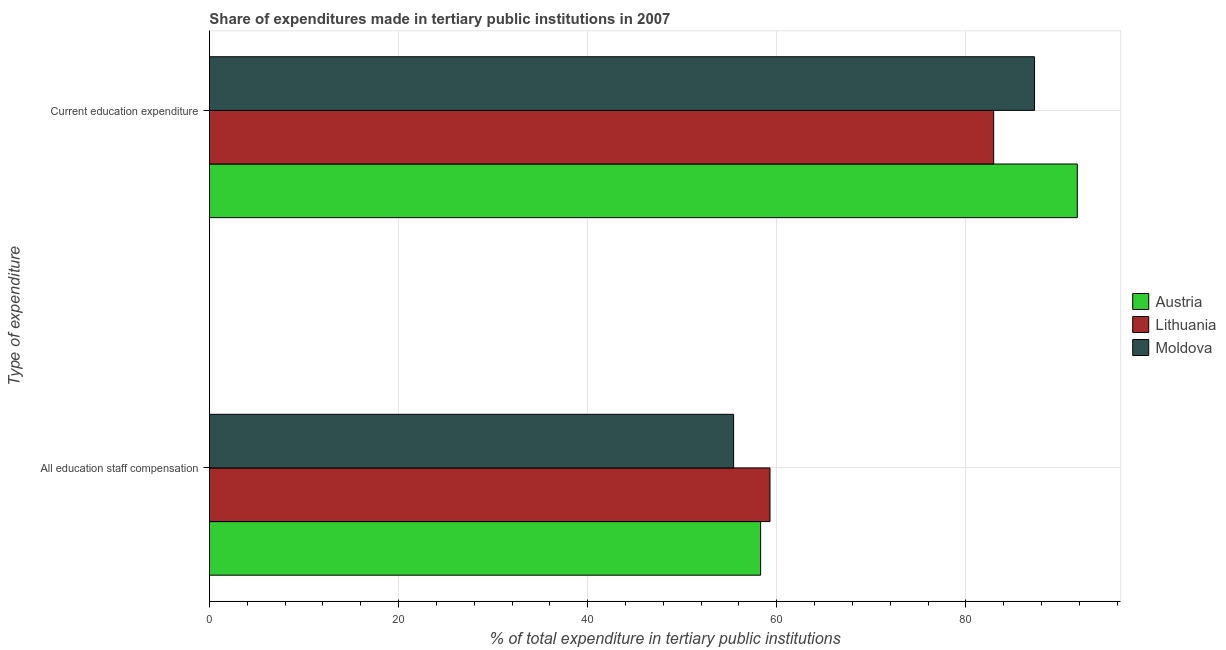Are the number of bars on each tick of the Y-axis equal?
Give a very brief answer. Yes. How many bars are there on the 2nd tick from the bottom?
Make the answer very short. 3. What is the label of the 2nd group of bars from the top?
Provide a succinct answer. All education staff compensation. What is the expenditure in staff compensation in Austria?
Provide a succinct answer. 58.29. Across all countries, what is the maximum expenditure in education?
Offer a very short reply. 91.79. Across all countries, what is the minimum expenditure in staff compensation?
Keep it short and to the point. 55.44. In which country was the expenditure in education maximum?
Your answer should be very brief. Austria. In which country was the expenditure in staff compensation minimum?
Keep it short and to the point. Moldova. What is the total expenditure in staff compensation in the graph?
Your answer should be very brief. 173.02. What is the difference between the expenditure in education in Moldova and that in Lithuania?
Offer a very short reply. 4.32. What is the difference between the expenditure in staff compensation in Moldova and the expenditure in education in Lithuania?
Offer a very short reply. -27.5. What is the average expenditure in staff compensation per country?
Keep it short and to the point. 57.67. What is the difference between the expenditure in education and expenditure in staff compensation in Moldova?
Offer a very short reply. 31.83. What is the ratio of the expenditure in education in Austria to that in Moldova?
Offer a terse response. 1.05. Is the expenditure in education in Austria less than that in Moldova?
Ensure brevity in your answer.  No. In how many countries, is the expenditure in staff compensation greater than the average expenditure in staff compensation taken over all countries?
Ensure brevity in your answer.  2. What does the 2nd bar from the top in All education staff compensation represents?
Give a very brief answer. Lithuania. What does the 2nd bar from the bottom in Current education expenditure represents?
Your answer should be very brief. Lithuania. How many bars are there?
Ensure brevity in your answer.  6. How many countries are there in the graph?
Your answer should be compact. 3. What is the difference between two consecutive major ticks on the X-axis?
Keep it short and to the point. 20. Are the values on the major ticks of X-axis written in scientific E-notation?
Provide a succinct answer. No. Where does the legend appear in the graph?
Offer a terse response. Center right. What is the title of the graph?
Give a very brief answer. Share of expenditures made in tertiary public institutions in 2007. Does "Georgia" appear as one of the legend labels in the graph?
Give a very brief answer. No. What is the label or title of the X-axis?
Ensure brevity in your answer.  % of total expenditure in tertiary public institutions. What is the label or title of the Y-axis?
Your response must be concise. Type of expenditure. What is the % of total expenditure in tertiary public institutions in Austria in All education staff compensation?
Your answer should be very brief. 58.29. What is the % of total expenditure in tertiary public institutions of Lithuania in All education staff compensation?
Ensure brevity in your answer.  59.29. What is the % of total expenditure in tertiary public institutions of Moldova in All education staff compensation?
Offer a very short reply. 55.44. What is the % of total expenditure in tertiary public institutions of Austria in Current education expenditure?
Ensure brevity in your answer.  91.79. What is the % of total expenditure in tertiary public institutions of Lithuania in Current education expenditure?
Your response must be concise. 82.94. What is the % of total expenditure in tertiary public institutions of Moldova in Current education expenditure?
Your response must be concise. 87.26. Across all Type of expenditure, what is the maximum % of total expenditure in tertiary public institutions in Austria?
Offer a terse response. 91.79. Across all Type of expenditure, what is the maximum % of total expenditure in tertiary public institutions in Lithuania?
Offer a terse response. 82.94. Across all Type of expenditure, what is the maximum % of total expenditure in tertiary public institutions in Moldova?
Ensure brevity in your answer.  87.26. Across all Type of expenditure, what is the minimum % of total expenditure in tertiary public institutions in Austria?
Give a very brief answer. 58.29. Across all Type of expenditure, what is the minimum % of total expenditure in tertiary public institutions in Lithuania?
Your response must be concise. 59.29. Across all Type of expenditure, what is the minimum % of total expenditure in tertiary public institutions in Moldova?
Keep it short and to the point. 55.44. What is the total % of total expenditure in tertiary public institutions in Austria in the graph?
Your response must be concise. 150.08. What is the total % of total expenditure in tertiary public institutions in Lithuania in the graph?
Keep it short and to the point. 142.23. What is the total % of total expenditure in tertiary public institutions of Moldova in the graph?
Make the answer very short. 142.7. What is the difference between the % of total expenditure in tertiary public institutions of Austria in All education staff compensation and that in Current education expenditure?
Offer a terse response. -33.49. What is the difference between the % of total expenditure in tertiary public institutions of Lithuania in All education staff compensation and that in Current education expenditure?
Your answer should be very brief. -23.66. What is the difference between the % of total expenditure in tertiary public institutions of Moldova in All education staff compensation and that in Current education expenditure?
Offer a terse response. -31.83. What is the difference between the % of total expenditure in tertiary public institutions of Austria in All education staff compensation and the % of total expenditure in tertiary public institutions of Lithuania in Current education expenditure?
Your answer should be very brief. -24.65. What is the difference between the % of total expenditure in tertiary public institutions in Austria in All education staff compensation and the % of total expenditure in tertiary public institutions in Moldova in Current education expenditure?
Provide a succinct answer. -28.97. What is the difference between the % of total expenditure in tertiary public institutions in Lithuania in All education staff compensation and the % of total expenditure in tertiary public institutions in Moldova in Current education expenditure?
Keep it short and to the point. -27.98. What is the average % of total expenditure in tertiary public institutions of Austria per Type of expenditure?
Offer a very short reply. 75.04. What is the average % of total expenditure in tertiary public institutions of Lithuania per Type of expenditure?
Keep it short and to the point. 71.11. What is the average % of total expenditure in tertiary public institutions in Moldova per Type of expenditure?
Your answer should be very brief. 71.35. What is the difference between the % of total expenditure in tertiary public institutions in Austria and % of total expenditure in tertiary public institutions in Lithuania in All education staff compensation?
Provide a succinct answer. -0.99. What is the difference between the % of total expenditure in tertiary public institutions in Austria and % of total expenditure in tertiary public institutions in Moldova in All education staff compensation?
Your response must be concise. 2.86. What is the difference between the % of total expenditure in tertiary public institutions in Lithuania and % of total expenditure in tertiary public institutions in Moldova in All education staff compensation?
Make the answer very short. 3.85. What is the difference between the % of total expenditure in tertiary public institutions in Austria and % of total expenditure in tertiary public institutions in Lithuania in Current education expenditure?
Keep it short and to the point. 8.85. What is the difference between the % of total expenditure in tertiary public institutions of Austria and % of total expenditure in tertiary public institutions of Moldova in Current education expenditure?
Offer a terse response. 4.52. What is the difference between the % of total expenditure in tertiary public institutions of Lithuania and % of total expenditure in tertiary public institutions of Moldova in Current education expenditure?
Ensure brevity in your answer.  -4.32. What is the ratio of the % of total expenditure in tertiary public institutions in Austria in All education staff compensation to that in Current education expenditure?
Give a very brief answer. 0.64. What is the ratio of the % of total expenditure in tertiary public institutions of Lithuania in All education staff compensation to that in Current education expenditure?
Your response must be concise. 0.71. What is the ratio of the % of total expenditure in tertiary public institutions of Moldova in All education staff compensation to that in Current education expenditure?
Offer a very short reply. 0.64. What is the difference between the highest and the second highest % of total expenditure in tertiary public institutions in Austria?
Ensure brevity in your answer.  33.49. What is the difference between the highest and the second highest % of total expenditure in tertiary public institutions in Lithuania?
Make the answer very short. 23.66. What is the difference between the highest and the second highest % of total expenditure in tertiary public institutions in Moldova?
Your answer should be compact. 31.83. What is the difference between the highest and the lowest % of total expenditure in tertiary public institutions in Austria?
Your response must be concise. 33.49. What is the difference between the highest and the lowest % of total expenditure in tertiary public institutions in Lithuania?
Offer a terse response. 23.66. What is the difference between the highest and the lowest % of total expenditure in tertiary public institutions in Moldova?
Offer a terse response. 31.83. 